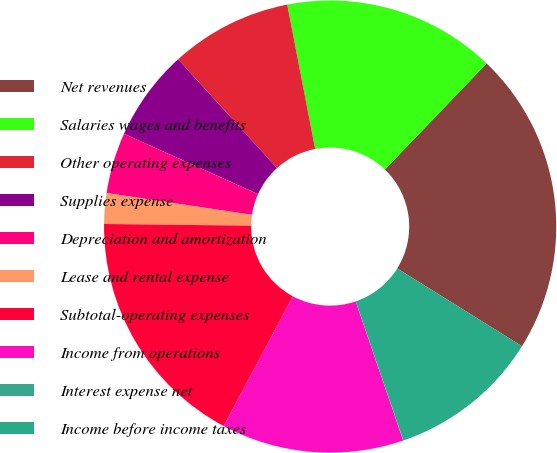Convert chart to OTSL. <chart><loc_0><loc_0><loc_500><loc_500><pie_chart><fcel>Net revenues<fcel>Salaries wages and benefits<fcel>Other operating expenses<fcel>Supplies expense<fcel>Depreciation and amortization<fcel>Lease and rental expense<fcel>Subtotal-operating expenses<fcel>Income from operations<fcel>Interest expense net<fcel>Income before income taxes<nl><fcel>21.71%<fcel>15.21%<fcel>8.7%<fcel>6.53%<fcel>4.36%<fcel>2.19%<fcel>17.38%<fcel>13.04%<fcel>0.02%<fcel>10.87%<nl></chart> 